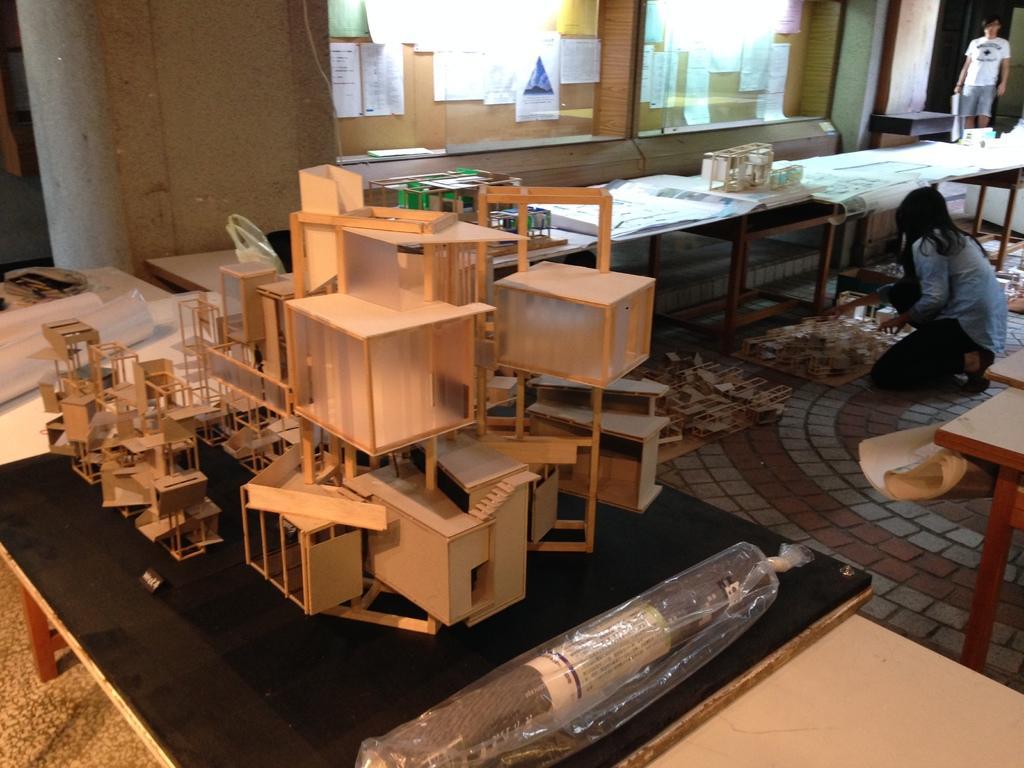Describe this image in one or two sentences. In this picture I can see a wooden objects on the black color wooden table. In the background I can see some papers attached to the wall. On the right side I can see tables on which I can see some objects on them. I can also see a woman is sitting and a person is standing. 